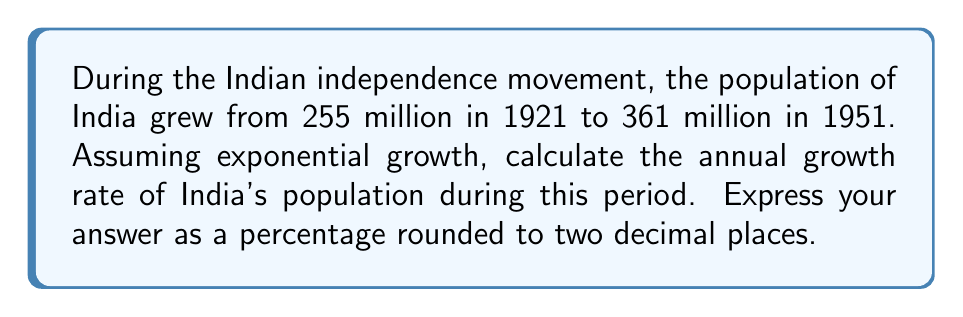Solve this math problem. Let's approach this step-by-step using the exponential growth formula:

1) The exponential growth formula is:
   $$A = P(1 + r)^t$$
   where A is the final amount, P is the initial amount, r is the annual growth rate, and t is the time in years.

2) We know:
   P = 255 million (initial population in 1921)
   A = 361 million (final population in 1951)
   t = 30 years (from 1921 to 1951)

3) Plugging these values into the formula:
   $$361 = 255(1 + r)^{30}$$

4) Divide both sides by 255:
   $$\frac{361}{255} = (1 + r)^{30}$$

5) Take the 30th root of both sides:
   $$\sqrt[30]{\frac{361}{255}} = 1 + r$$

6) Subtract 1 from both sides:
   $$\sqrt[30]{\frac{361}{255}} - 1 = r$$

7) Calculate:
   $$r \approx 0.0117$$

8) Convert to a percentage by multiplying by 100:
   $$r \approx 1.17\%$$

9) Round to two decimal places:
   $$r \approx 1.17\%$$
Answer: 1.17% 